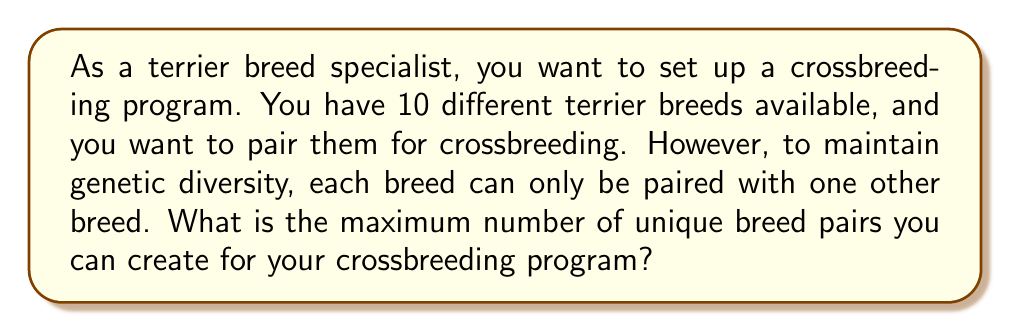Provide a solution to this math problem. This problem can be modeled using graph theory, specifically as a maximum matching problem in a complete graph.

1) Each terrier breed can be represented as a vertex in a graph.
2) Since each breed can potentially be paired with any other breed, we have a complete graph with 10 vertices.
3) A pairing of two breeds for crossbreeding is represented by an edge in the graph.
4) The constraint that each breed can only be paired with one other breed means we are looking for a matching in the graph.
5) We want to find the maximum matching, which will give us the maximum number of breed pairs.

In a complete graph with $n$ vertices, where $n$ is even, the maximum matching always contains $\frac{n}{2}$ edges. This is because each vertex can be paired with exactly one other vertex, and all vertices can be used.

In this case, we have $n = 10$ vertices (breeds).

The maximum number of pairs is therefore:

$$ \text{Maximum pairs} = \frac{n}{2} = \frac{10}{2} = 5 $$

This means we can create 5 unique breed pairs, involving all 10 breeds, for the crossbreeding program.

[asy]
unitsize(30);
pair[] vertices = {dir(0), dir(36), dir(72), dir(108), dir(144), dir(180), dir(216), dir(252), dir(288), dir(324)};
for(int i = 0; i < 10; ++i)
  for(int j = i+1; j < 10; ++j)
    draw(vertices[i]--vertices[j], gray);
for(int i = 0; i < 10; ++i)
  dot(vertices[i], red);
draw(vertices[0]--vertices[5], blue+1);
draw(vertices[1]--vertices[6], blue+1);
draw(vertices[2]--vertices[7], blue+1);
draw(vertices[3]--vertices[8], blue+1);
draw(vertices[4]--vertices[9], blue+1);
[/asy]

In the diagram above, the red dots represent the 10 terrier breeds, the gray lines show all possible pairings, and the blue lines represent one possible maximum matching of 5 pairs.
Answer: The maximum number of unique terrier breed pairs for crossbreeding is 5. 